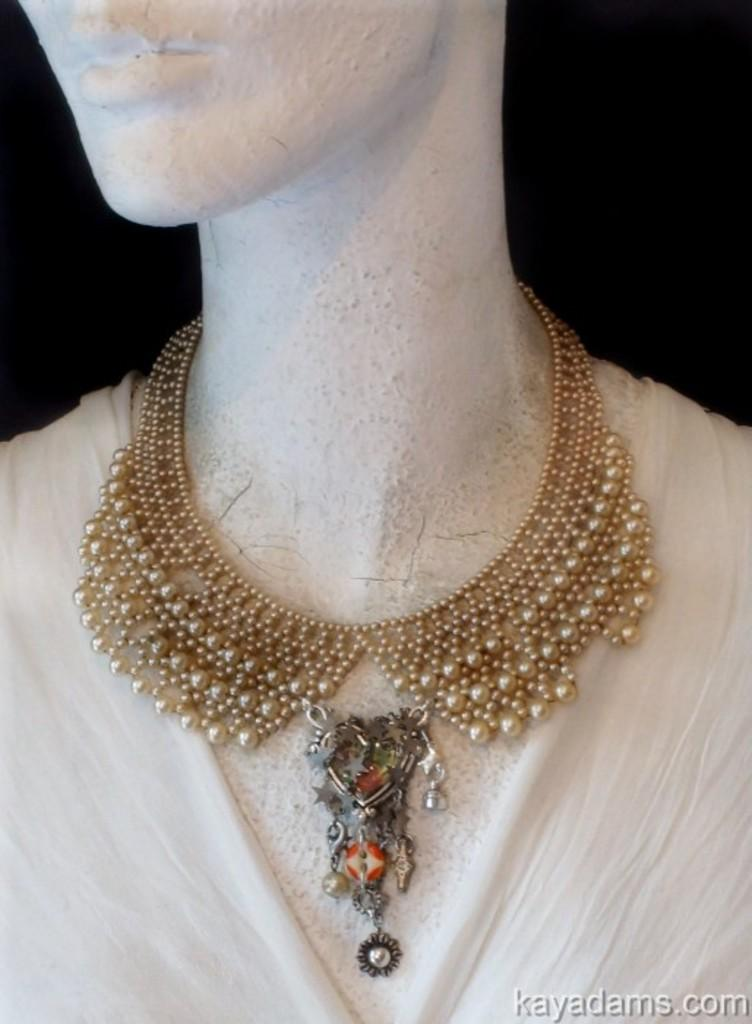What is the main subject in the image? There is a mannequin in the image. What color is the mannequin? The mannequin is white in color. What accessory is the mannequin wearing? There is a gold-colored necklace on the mannequin. What color is the background of the image? The background of the image is black in color. What type of lunchroom is depicted in the image? There is no lunchroom present in the image; it features a mannequin with a gold-colored necklace against a black background. Can you tell me how much hate is visible in the image? There is no hate present in the image; it is a neutral representation of a mannequin with a necklace. 